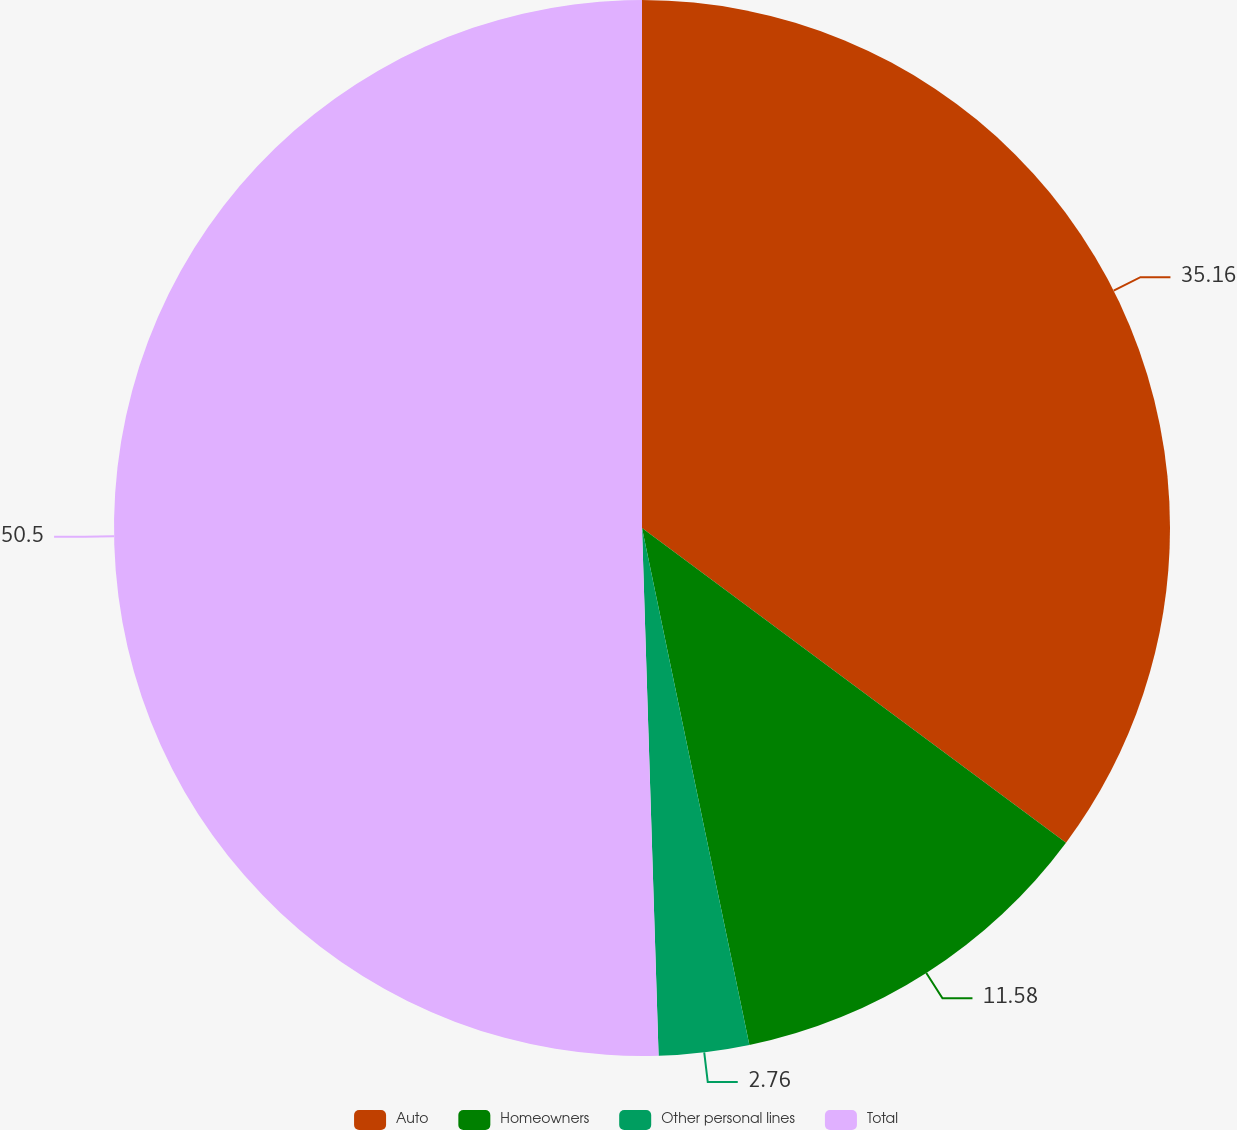Convert chart. <chart><loc_0><loc_0><loc_500><loc_500><pie_chart><fcel>Auto<fcel>Homeowners<fcel>Other personal lines<fcel>Total<nl><fcel>35.16%<fcel>11.58%<fcel>2.76%<fcel>50.5%<nl></chart> 